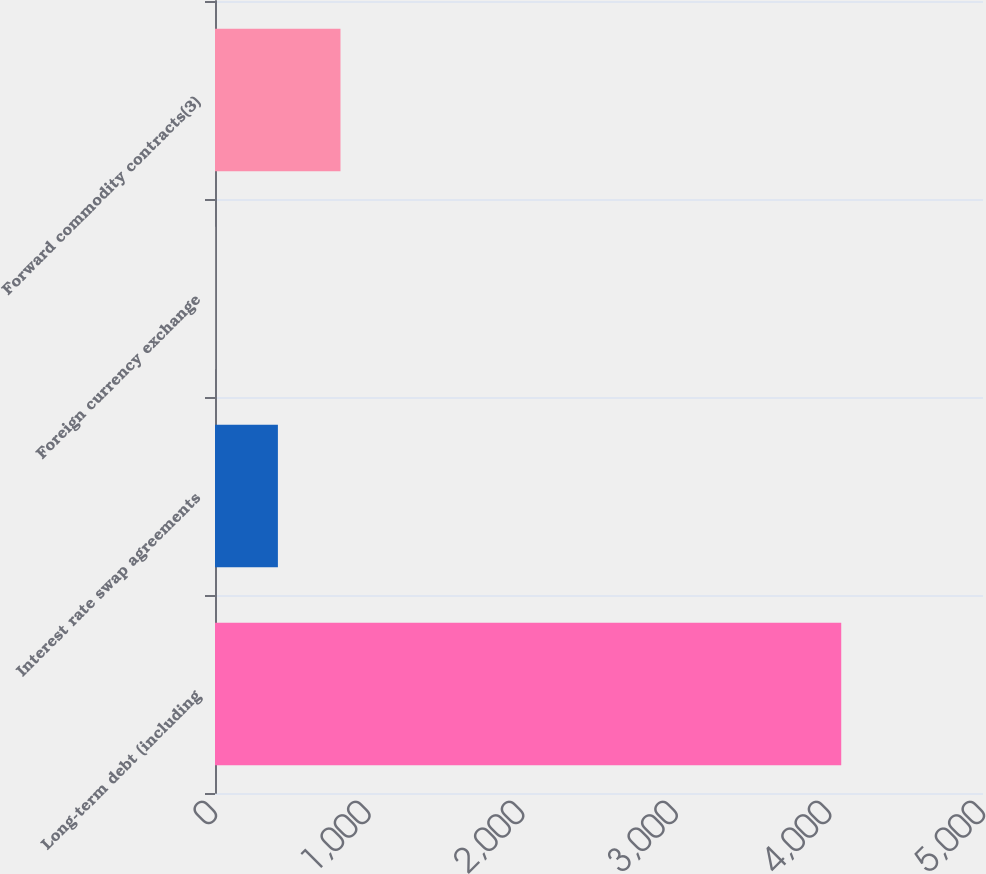Convert chart to OTSL. <chart><loc_0><loc_0><loc_500><loc_500><bar_chart><fcel>Long-term debt (including<fcel>Interest rate swap agreements<fcel>Foreign currency exchange<fcel>Forward commodity contracts(3)<nl><fcel>4077<fcel>409.5<fcel>2<fcel>817<nl></chart> 